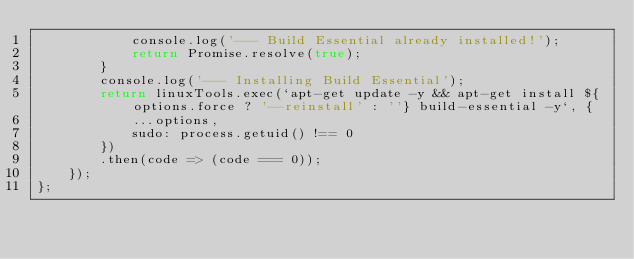Convert code to text. <code><loc_0><loc_0><loc_500><loc_500><_JavaScript_>            console.log('--- Build Essential already installed!');
            return Promise.resolve(true);
        }
        console.log('--- Installing Build Essential');
        return linuxTools.exec(`apt-get update -y && apt-get install ${options.force ? '--reinstall' : ''} build-essential -y`, {
            ...options,
            sudo: process.getuid() !== 0
        })
        .then(code => (code === 0));
    });
};
</code> 